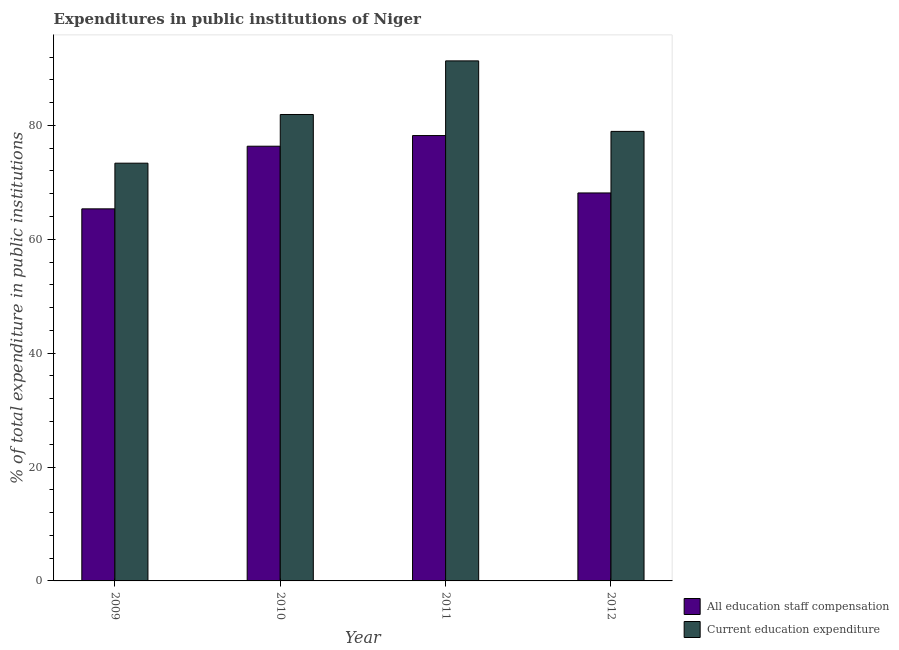How many different coloured bars are there?
Your response must be concise. 2. Are the number of bars per tick equal to the number of legend labels?
Keep it short and to the point. Yes. Are the number of bars on each tick of the X-axis equal?
Your response must be concise. Yes. How many bars are there on the 4th tick from the right?
Provide a succinct answer. 2. What is the label of the 3rd group of bars from the left?
Your answer should be very brief. 2011. In how many cases, is the number of bars for a given year not equal to the number of legend labels?
Offer a very short reply. 0. What is the expenditure in staff compensation in 2009?
Offer a very short reply. 65.34. Across all years, what is the maximum expenditure in staff compensation?
Make the answer very short. 78.21. Across all years, what is the minimum expenditure in education?
Offer a very short reply. 73.36. In which year was the expenditure in staff compensation maximum?
Your answer should be very brief. 2011. What is the total expenditure in staff compensation in the graph?
Provide a short and direct response. 288.02. What is the difference between the expenditure in education in 2010 and that in 2011?
Give a very brief answer. -9.41. What is the difference between the expenditure in education in 2011 and the expenditure in staff compensation in 2009?
Make the answer very short. 17.97. What is the average expenditure in staff compensation per year?
Offer a terse response. 72. In the year 2012, what is the difference between the expenditure in education and expenditure in staff compensation?
Your answer should be very brief. 0. What is the ratio of the expenditure in staff compensation in 2009 to that in 2012?
Keep it short and to the point. 0.96. Is the expenditure in education in 2009 less than that in 2010?
Give a very brief answer. Yes. Is the difference between the expenditure in education in 2010 and 2011 greater than the difference between the expenditure in staff compensation in 2010 and 2011?
Ensure brevity in your answer.  No. What is the difference between the highest and the second highest expenditure in staff compensation?
Keep it short and to the point. 1.87. What is the difference between the highest and the lowest expenditure in education?
Ensure brevity in your answer.  17.97. Is the sum of the expenditure in staff compensation in 2010 and 2012 greater than the maximum expenditure in education across all years?
Provide a short and direct response. Yes. What does the 2nd bar from the left in 2009 represents?
Offer a very short reply. Current education expenditure. What does the 2nd bar from the right in 2009 represents?
Make the answer very short. All education staff compensation. How many bars are there?
Provide a succinct answer. 8. How many years are there in the graph?
Provide a succinct answer. 4. Are the values on the major ticks of Y-axis written in scientific E-notation?
Make the answer very short. No. Where does the legend appear in the graph?
Provide a short and direct response. Bottom right. How many legend labels are there?
Provide a short and direct response. 2. What is the title of the graph?
Offer a very short reply. Expenditures in public institutions of Niger. Does "Tetanus" appear as one of the legend labels in the graph?
Your answer should be very brief. No. What is the label or title of the Y-axis?
Provide a succinct answer. % of total expenditure in public institutions. What is the % of total expenditure in public institutions of All education staff compensation in 2009?
Offer a terse response. 65.34. What is the % of total expenditure in public institutions in Current education expenditure in 2009?
Keep it short and to the point. 73.36. What is the % of total expenditure in public institutions of All education staff compensation in 2010?
Your answer should be compact. 76.34. What is the % of total expenditure in public institutions of Current education expenditure in 2010?
Your answer should be compact. 81.91. What is the % of total expenditure in public institutions in All education staff compensation in 2011?
Keep it short and to the point. 78.21. What is the % of total expenditure in public institutions of Current education expenditure in 2011?
Your answer should be compact. 91.32. What is the % of total expenditure in public institutions of All education staff compensation in 2012?
Offer a very short reply. 68.13. What is the % of total expenditure in public institutions in Current education expenditure in 2012?
Offer a very short reply. 78.94. Across all years, what is the maximum % of total expenditure in public institutions in All education staff compensation?
Provide a succinct answer. 78.21. Across all years, what is the maximum % of total expenditure in public institutions in Current education expenditure?
Offer a very short reply. 91.32. Across all years, what is the minimum % of total expenditure in public institutions in All education staff compensation?
Offer a terse response. 65.34. Across all years, what is the minimum % of total expenditure in public institutions in Current education expenditure?
Ensure brevity in your answer.  73.36. What is the total % of total expenditure in public institutions of All education staff compensation in the graph?
Your answer should be very brief. 288.02. What is the total % of total expenditure in public institutions in Current education expenditure in the graph?
Keep it short and to the point. 325.53. What is the difference between the % of total expenditure in public institutions of All education staff compensation in 2009 and that in 2010?
Your answer should be very brief. -11. What is the difference between the % of total expenditure in public institutions in Current education expenditure in 2009 and that in 2010?
Your answer should be very brief. -8.55. What is the difference between the % of total expenditure in public institutions in All education staff compensation in 2009 and that in 2011?
Provide a short and direct response. -12.87. What is the difference between the % of total expenditure in public institutions of Current education expenditure in 2009 and that in 2011?
Offer a very short reply. -17.97. What is the difference between the % of total expenditure in public institutions in All education staff compensation in 2009 and that in 2012?
Give a very brief answer. -2.79. What is the difference between the % of total expenditure in public institutions of Current education expenditure in 2009 and that in 2012?
Provide a succinct answer. -5.58. What is the difference between the % of total expenditure in public institutions in All education staff compensation in 2010 and that in 2011?
Offer a very short reply. -1.87. What is the difference between the % of total expenditure in public institutions of Current education expenditure in 2010 and that in 2011?
Keep it short and to the point. -9.41. What is the difference between the % of total expenditure in public institutions in All education staff compensation in 2010 and that in 2012?
Give a very brief answer. 8.21. What is the difference between the % of total expenditure in public institutions in Current education expenditure in 2010 and that in 2012?
Your answer should be compact. 2.97. What is the difference between the % of total expenditure in public institutions of All education staff compensation in 2011 and that in 2012?
Provide a short and direct response. 10.08. What is the difference between the % of total expenditure in public institutions in Current education expenditure in 2011 and that in 2012?
Your response must be concise. 12.38. What is the difference between the % of total expenditure in public institutions in All education staff compensation in 2009 and the % of total expenditure in public institutions in Current education expenditure in 2010?
Your answer should be compact. -16.57. What is the difference between the % of total expenditure in public institutions of All education staff compensation in 2009 and the % of total expenditure in public institutions of Current education expenditure in 2011?
Provide a short and direct response. -25.99. What is the difference between the % of total expenditure in public institutions in All education staff compensation in 2009 and the % of total expenditure in public institutions in Current education expenditure in 2012?
Offer a terse response. -13.6. What is the difference between the % of total expenditure in public institutions in All education staff compensation in 2010 and the % of total expenditure in public institutions in Current education expenditure in 2011?
Ensure brevity in your answer.  -14.98. What is the difference between the % of total expenditure in public institutions of All education staff compensation in 2010 and the % of total expenditure in public institutions of Current education expenditure in 2012?
Your answer should be compact. -2.6. What is the difference between the % of total expenditure in public institutions in All education staff compensation in 2011 and the % of total expenditure in public institutions in Current education expenditure in 2012?
Offer a terse response. -0.73. What is the average % of total expenditure in public institutions in All education staff compensation per year?
Your response must be concise. 72. What is the average % of total expenditure in public institutions in Current education expenditure per year?
Offer a terse response. 81.38. In the year 2009, what is the difference between the % of total expenditure in public institutions in All education staff compensation and % of total expenditure in public institutions in Current education expenditure?
Give a very brief answer. -8.02. In the year 2010, what is the difference between the % of total expenditure in public institutions of All education staff compensation and % of total expenditure in public institutions of Current education expenditure?
Keep it short and to the point. -5.57. In the year 2011, what is the difference between the % of total expenditure in public institutions of All education staff compensation and % of total expenditure in public institutions of Current education expenditure?
Your answer should be compact. -13.11. In the year 2012, what is the difference between the % of total expenditure in public institutions of All education staff compensation and % of total expenditure in public institutions of Current education expenditure?
Provide a succinct answer. -10.81. What is the ratio of the % of total expenditure in public institutions in All education staff compensation in 2009 to that in 2010?
Make the answer very short. 0.86. What is the ratio of the % of total expenditure in public institutions of Current education expenditure in 2009 to that in 2010?
Make the answer very short. 0.9. What is the ratio of the % of total expenditure in public institutions in All education staff compensation in 2009 to that in 2011?
Your answer should be compact. 0.84. What is the ratio of the % of total expenditure in public institutions in Current education expenditure in 2009 to that in 2011?
Provide a short and direct response. 0.8. What is the ratio of the % of total expenditure in public institutions of All education staff compensation in 2009 to that in 2012?
Ensure brevity in your answer.  0.96. What is the ratio of the % of total expenditure in public institutions of Current education expenditure in 2009 to that in 2012?
Offer a very short reply. 0.93. What is the ratio of the % of total expenditure in public institutions in All education staff compensation in 2010 to that in 2011?
Your answer should be very brief. 0.98. What is the ratio of the % of total expenditure in public institutions of Current education expenditure in 2010 to that in 2011?
Provide a succinct answer. 0.9. What is the ratio of the % of total expenditure in public institutions in All education staff compensation in 2010 to that in 2012?
Keep it short and to the point. 1.12. What is the ratio of the % of total expenditure in public institutions in Current education expenditure in 2010 to that in 2012?
Give a very brief answer. 1.04. What is the ratio of the % of total expenditure in public institutions in All education staff compensation in 2011 to that in 2012?
Offer a terse response. 1.15. What is the ratio of the % of total expenditure in public institutions in Current education expenditure in 2011 to that in 2012?
Your response must be concise. 1.16. What is the difference between the highest and the second highest % of total expenditure in public institutions in All education staff compensation?
Offer a terse response. 1.87. What is the difference between the highest and the second highest % of total expenditure in public institutions of Current education expenditure?
Your answer should be very brief. 9.41. What is the difference between the highest and the lowest % of total expenditure in public institutions of All education staff compensation?
Your answer should be very brief. 12.87. What is the difference between the highest and the lowest % of total expenditure in public institutions in Current education expenditure?
Your answer should be very brief. 17.97. 